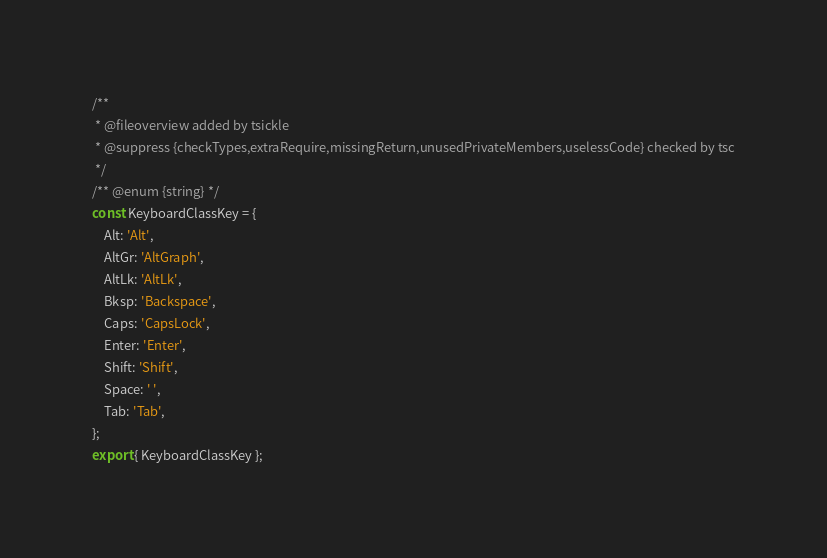Convert code to text. <code><loc_0><loc_0><loc_500><loc_500><_JavaScript_>/**
 * @fileoverview added by tsickle
 * @suppress {checkTypes,extraRequire,missingReturn,unusedPrivateMembers,uselessCode} checked by tsc
 */
/** @enum {string} */
const KeyboardClassKey = {
    Alt: 'Alt',
    AltGr: 'AltGraph',
    AltLk: 'AltLk',
    Bksp: 'Backspace',
    Caps: 'CapsLock',
    Enter: 'Enter',
    Shift: 'Shift',
    Space: ' ',
    Tab: 'Tab',
};
export { KeyboardClassKey };</code> 